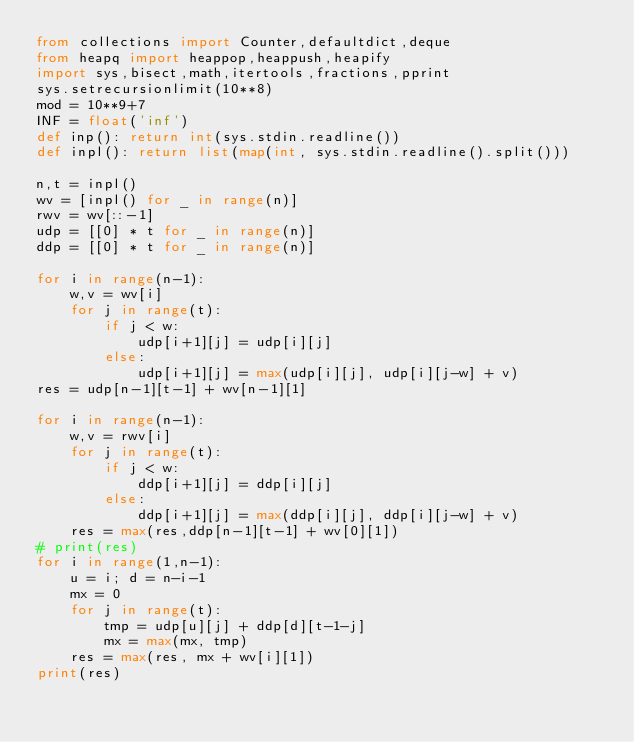Convert code to text. <code><loc_0><loc_0><loc_500><loc_500><_Python_>from collections import Counter,defaultdict,deque
from heapq import heappop,heappush,heapify
import sys,bisect,math,itertools,fractions,pprint
sys.setrecursionlimit(10**8)
mod = 10**9+7
INF = float('inf')
def inp(): return int(sys.stdin.readline())
def inpl(): return list(map(int, sys.stdin.readline().split()))

n,t = inpl()
wv = [inpl() for _ in range(n)]
rwv = wv[::-1]
udp = [[0] * t for _ in range(n)]
ddp = [[0] * t for _ in range(n)]

for i in range(n-1):
    w,v = wv[i]
    for j in range(t):
        if j < w:
            udp[i+1][j] = udp[i][j]
        else:
            udp[i+1][j] = max(udp[i][j], udp[i][j-w] + v)
res = udp[n-1][t-1] + wv[n-1][1]

for i in range(n-1):
    w,v = rwv[i]
    for j in range(t):
        if j < w:
            ddp[i+1][j] = ddp[i][j]
        else:
            ddp[i+1][j] = max(ddp[i][j], ddp[i][j-w] + v)
    res = max(res,ddp[n-1][t-1] + wv[0][1])
# print(res)
for i in range(1,n-1):
    u = i; d = n-i-1
    mx = 0
    for j in range(t):
        tmp = udp[u][j] + ddp[d][t-1-j]
        mx = max(mx, tmp)
    res = max(res, mx + wv[i][1])
print(res)</code> 